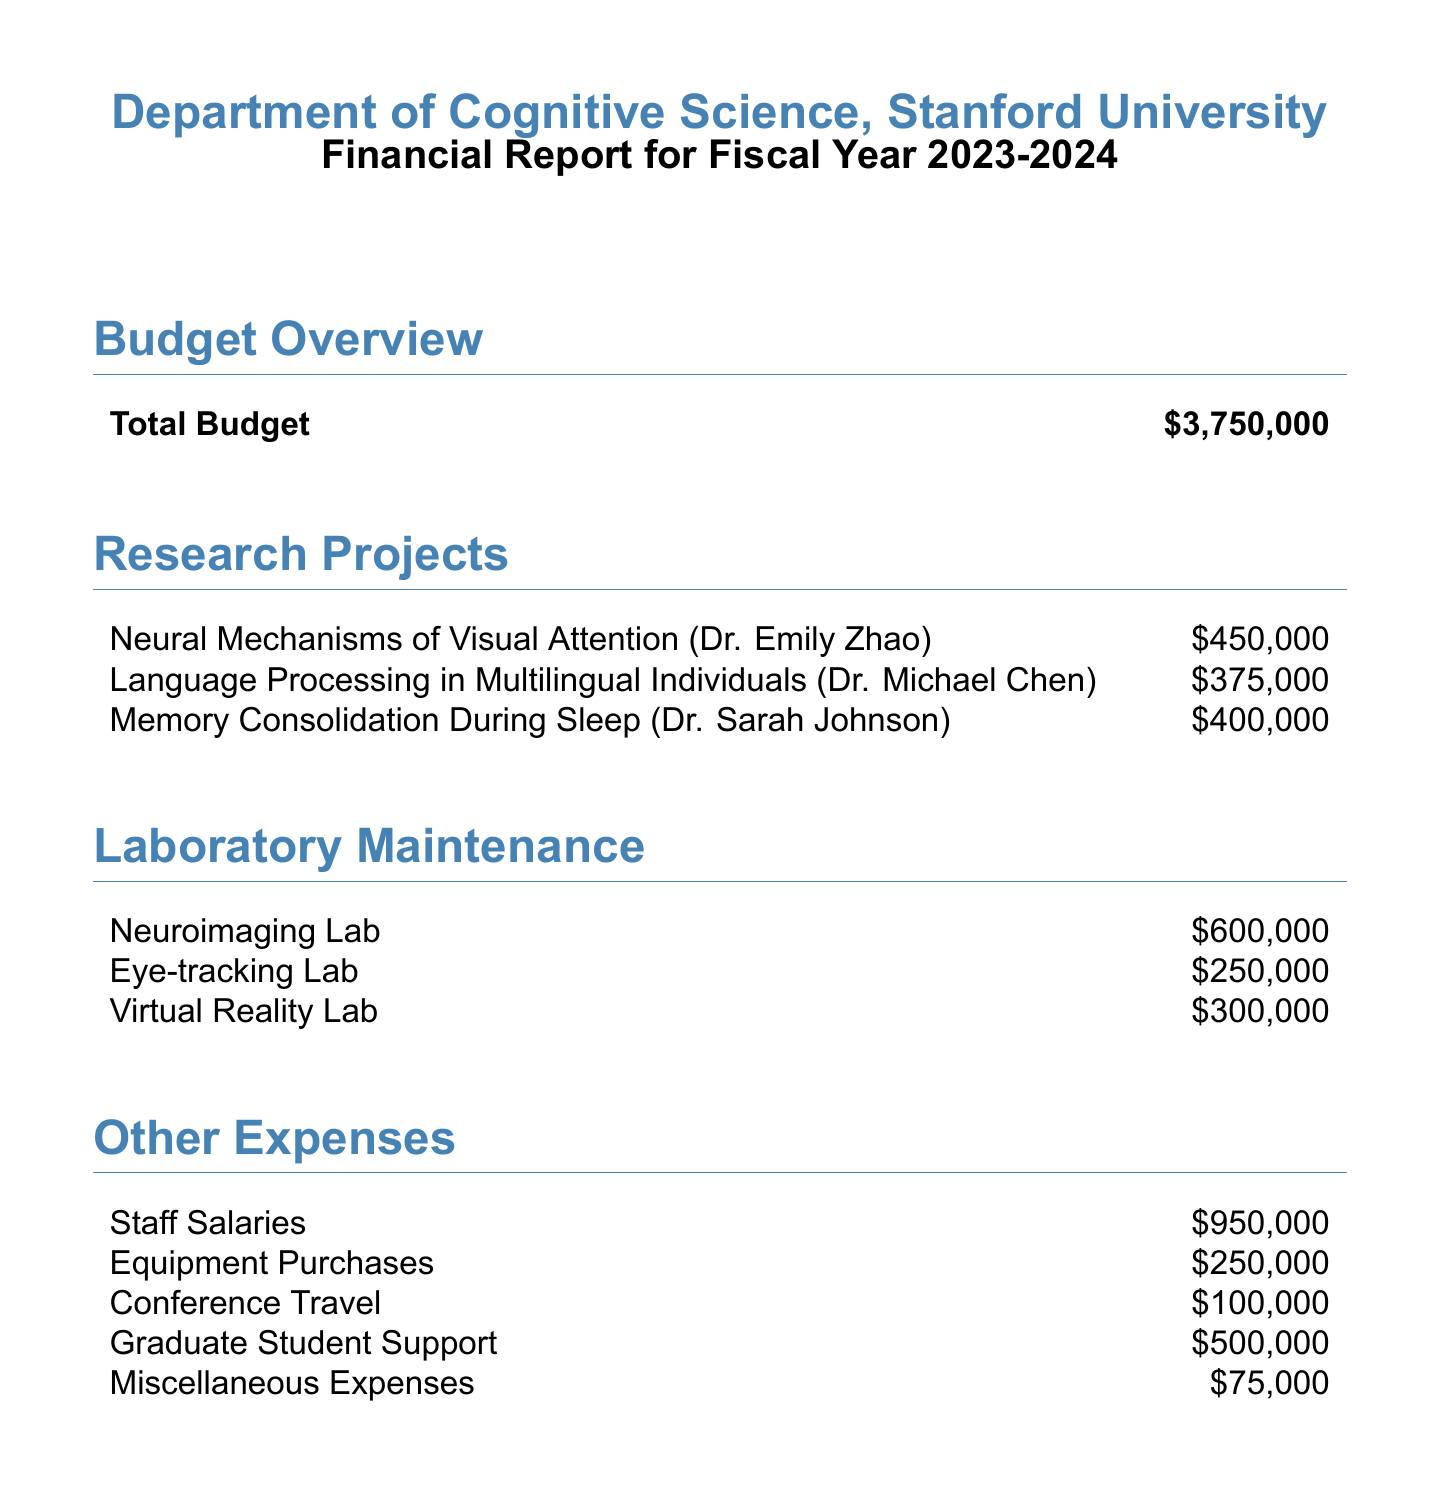What is the total budget for the fiscal year? The total budget for the fiscal year is stated in the budget overview section of the document.
Answer: $3,750,000 Who is the principal investigator for the Memory Consolidation During Sleep project? The principal investigator is mentioned alongside the project name in the research projects section.
Answer: Dr. Sarah Johnson How much is allocated to the Eye-tracking Lab for laboratory maintenance? The allocation for laboratory maintenance is specified in the laboratory maintenance section of the document.
Answer: $250,000 What is the total allocation for research projects? The total allocation can be calculated by adding the individual research project allocations listed in the document.
Answer: $1,225,000 Which expense category has the highest allocation? This question refers to the listed categories of expenses, requiring comparison between the amounts provided.
Answer: Staff Salaries What is the total amount allocated for graduate student support? The specific allocation for graduate student support is provided in the other expenses section.
Answer: $500,000 How many research projects are mentioned in the report? This requires counting the items listed under the research projects section.
Answer: 3 What percentage of the total budget is allocated for laboratory maintenance? This question requires calculating the percentage based on the total budget and the sum of laboratory maintenance allocations.
Answer: 24% What type of document is this? The nature of the document can be inferred from the content and title provided.
Answer: Financial Report Who is the principal investigator for the Language Processing in Multilingual Individuals project? The principal investigator is specifically mentioned with the research project title.
Answer: Dr. Michael Chen 